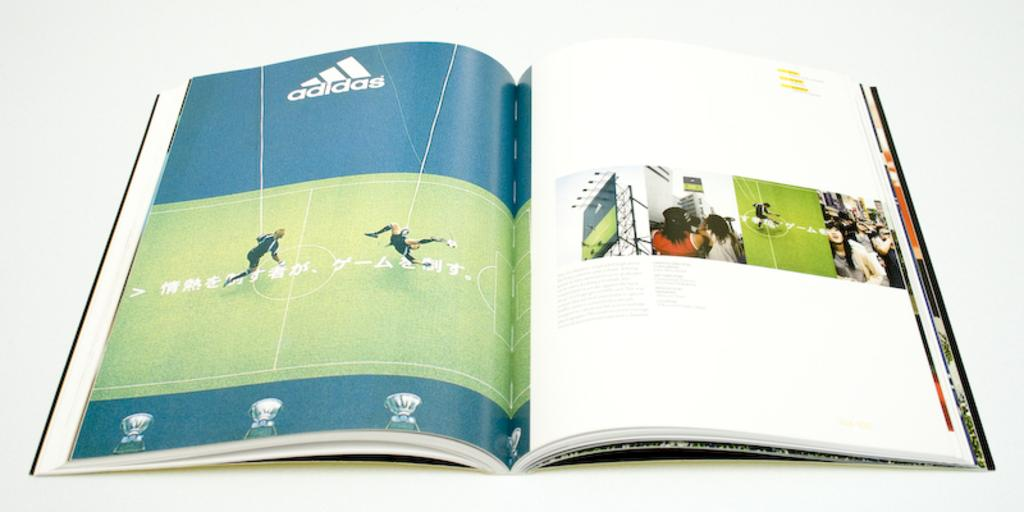<image>
Provide a brief description of the given image. A book is open to an advertisement for Adidas. 